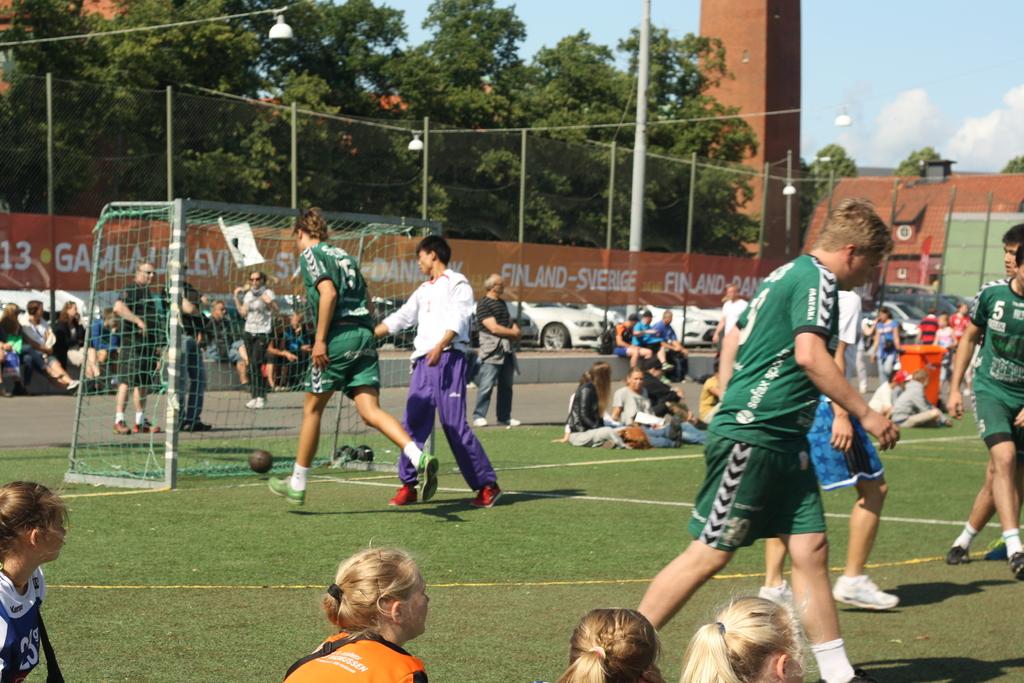What country is this in?
Make the answer very short. Finland. What number is the person on the far right?
Provide a succinct answer. 5. 